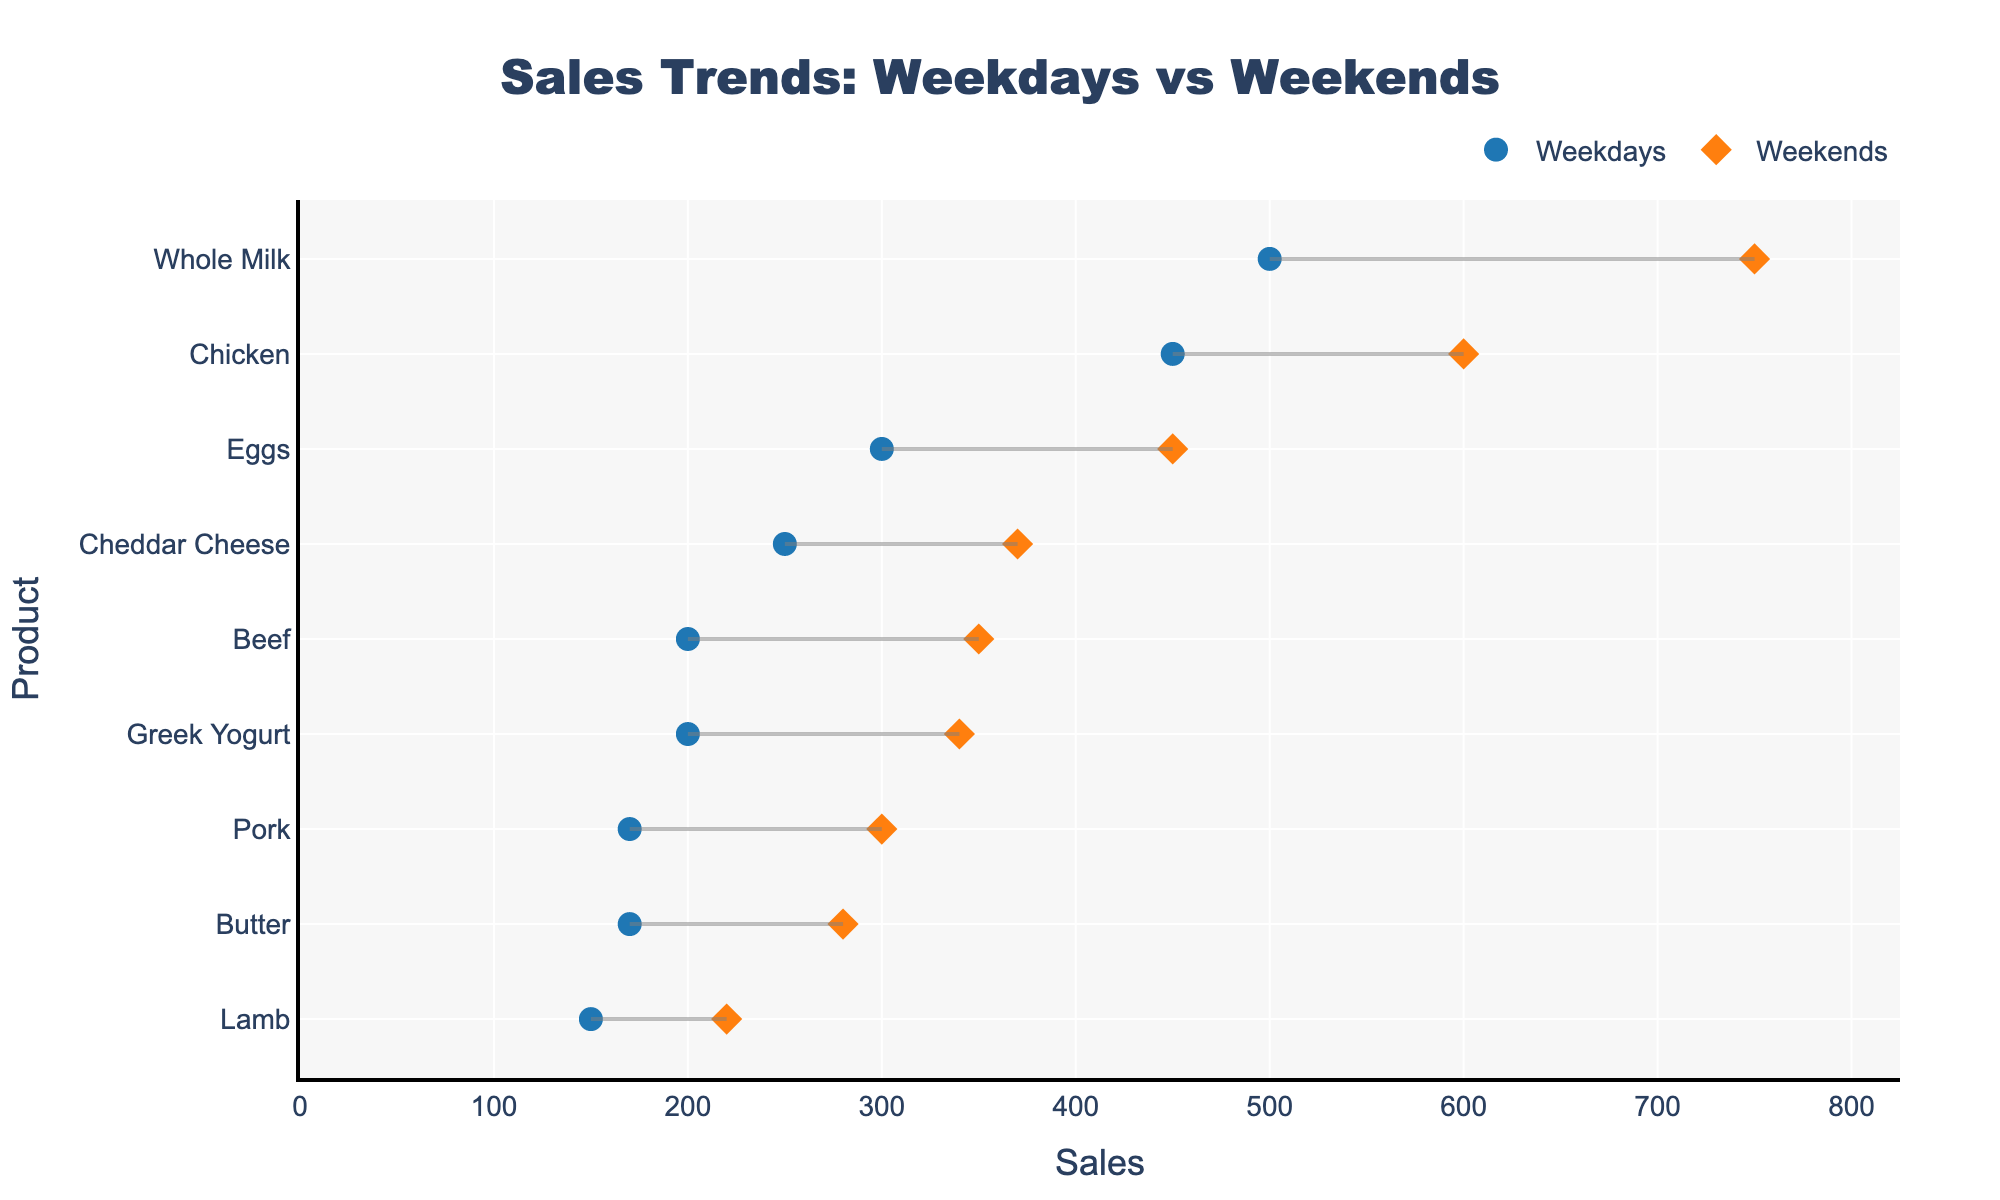what is the title of the plot? The title of the plot is usually displayed prominently at the top in bold, large font. It provides a context of what the plot is illustrating.
Answer: Sales Trends: Weekdays vs Weekends What color represents weekend sales? The color for weekend sales is typically indicated in the legend of the plot. For this figure, it is explicitly mentioned in the provided code snippet that the color for weekend sales markers is specified.
Answer: Orange What is the range of sales for Beef from weekdays to weekends? To determine the range, locate the markers for Beef on both the weekdays and weekends, and calculate the value difference between them. For Beef, the weekday sales are 200, and weekend sales are 350. The range is calculated as 350 - 200.
Answer: 150 Which product has the highest sales on weekdays? Identify the product with the highest marker position on the x-axis for the weekday sales. For weekdays, Whole Milk has a sales value of 500, which is the highest.
Answer: Whole Milk How does the sales of Greek Yogurt differ between weekdays and weekends? Compare the weekday and weekend sales values for Greek Yogurt by looking at their respective points. Weekday sales are 200, and weekend sales are 340. Calculate the difference as 340 - 200.
Answer: 140 Which store shows the most significant increase in sales from weekdays to weekends? Compare the difference in sales from weekdays to weekends across all products for each store. The Dairy Delight store’s Whole Milk shows the highest increase from 500 to 750, which is an increase of 250.
Answer: Dairy Delight On which day do Cheddar Cheese sales exceed Butter sales? Look at the sales values for Cheddar Cheese and Butter for both weekdays and weekends. For both weekday (250 vs. 170) and weekend sales (370 vs.280), Cheddar Cheese sales exceed Butter sales.
Answer: Both For Pork, what is the percentage increase in sales from weekdays to weekends? Calculate the percentage increase using the formula: ((weekend sales - weekday sales) / weekday sales) * 100. For Pork, this is ((300 - 170) / 170) * 100.
Answer: Approximately 76.47% What is the visual representation used to connect weekday and weekend sales in the plot? Observe the lines connecting the dots for each product. The lines indicate the difference and trend from weekday to weekend sales within each product category.
Answer: Lines How do sales of meat products (Beef, Lamb, Pork, and Chicken) generally compare on weekdays vs weekends? By examining the markers and their connecting lines for meat products, it is observed that weekend sales are consistently higher. Compare each product to confirm this trend.
Answer: Higher on weekends 